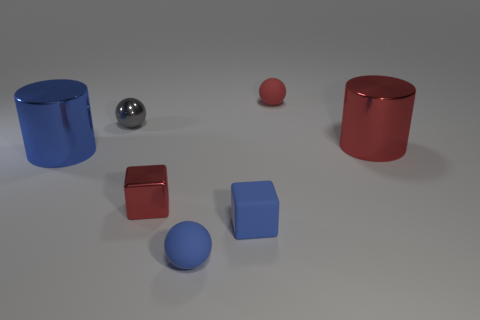The metallic cube is what color?
Give a very brief answer. Red. Is there anything else that is the same color as the rubber block?
Ensure brevity in your answer.  Yes. There is a big metallic cylinder to the right of the blue matte ball; is its color the same as the thing that is behind the gray metallic object?
Ensure brevity in your answer.  Yes. There is a small matte thing that is the same color as the small metal block; what is its shape?
Make the answer very short. Sphere. What number of small gray metal things are in front of the small blue block?
Your answer should be compact. 0. Is the shape of the big red shiny thing the same as the blue metal object?
Your response must be concise. Yes. What number of tiny objects are both in front of the blue metallic cylinder and right of the tiny red shiny block?
Give a very brief answer. 2. What number of objects are yellow things or metal cylinders that are left of the tiny shiny block?
Offer a terse response. 1. Are there more large red metallic cylinders than small cubes?
Your answer should be compact. No. There is a tiny red object that is on the right side of the rubber block; what shape is it?
Your response must be concise. Sphere. 